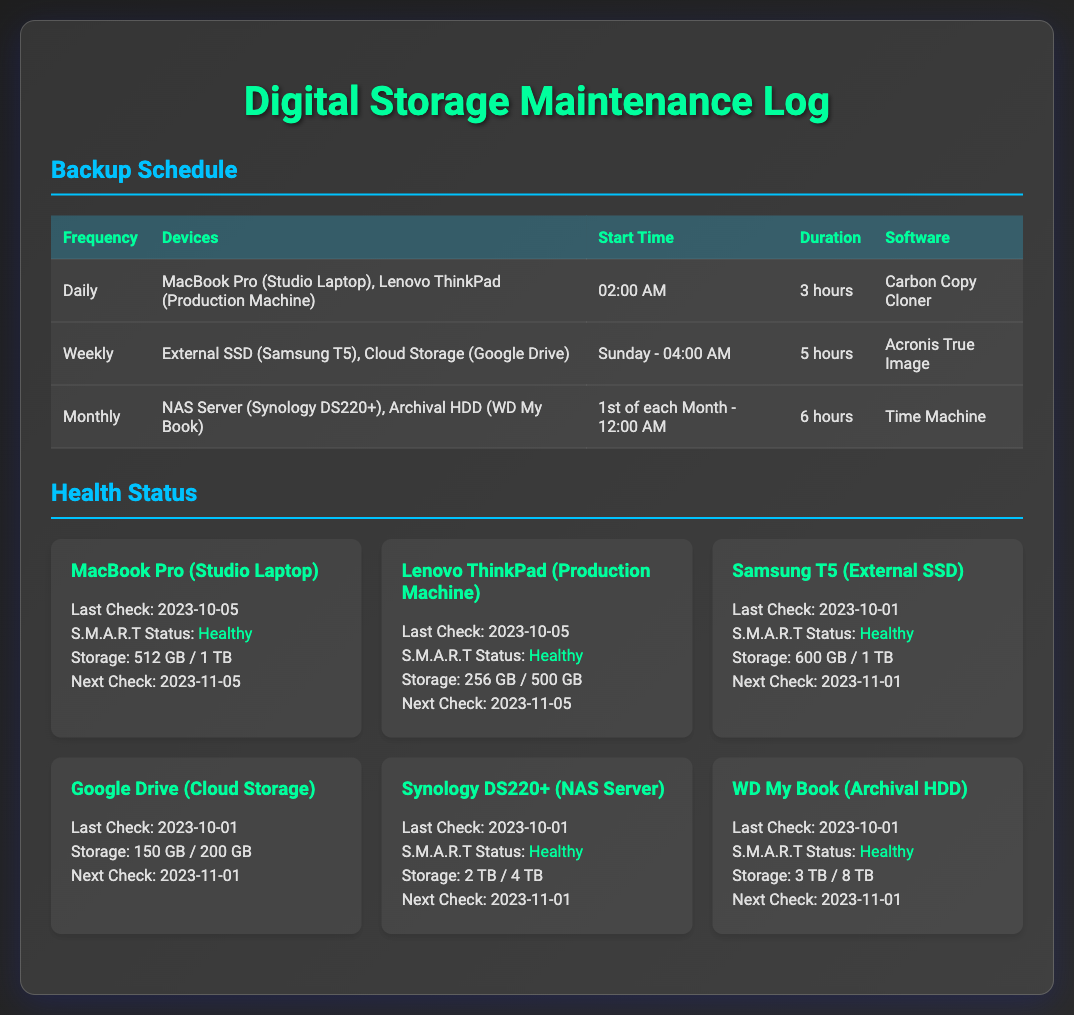what is the backup frequency for the MacBook Pro? The backup frequency for the MacBook Pro is listed as "Daily" in the schedule.
Answer: Daily what time does the weekly backup for Google Drive occur? The Google Drive backup is scheduled to occur on Sunday at "04:00 AM".
Answer: Sunday - 04:00 AM how long is the backup duration for the NAS Server? The backup duration for the NAS Server is 6 hours according to the schedule.
Answer: 6 hours what is the total storage capacity of the WD My Book? The total storage capacity of the WD My Book is "8 TB".
Answer: 8 TB when is the next health check for the Lenovo ThinkPad? The next health check for the Lenovo ThinkPad is scheduled for "2023-11-05".
Answer: 2023-11-05 how many devices are backed up daily? There are two devices backed up daily: "MacBook Pro (Studio Laptop), Lenovo ThinkPad (Production Machine)".
Answer: 2 what is the S.M.A.R.T status of the Samsung T5? The S.M.A.R.T status of the Samsung T5 is "Healthy".
Answer: Healthy which software is used for weekly backups? The software used for weekly backups is "Acronis True Image".
Answer: Acronis True Image 